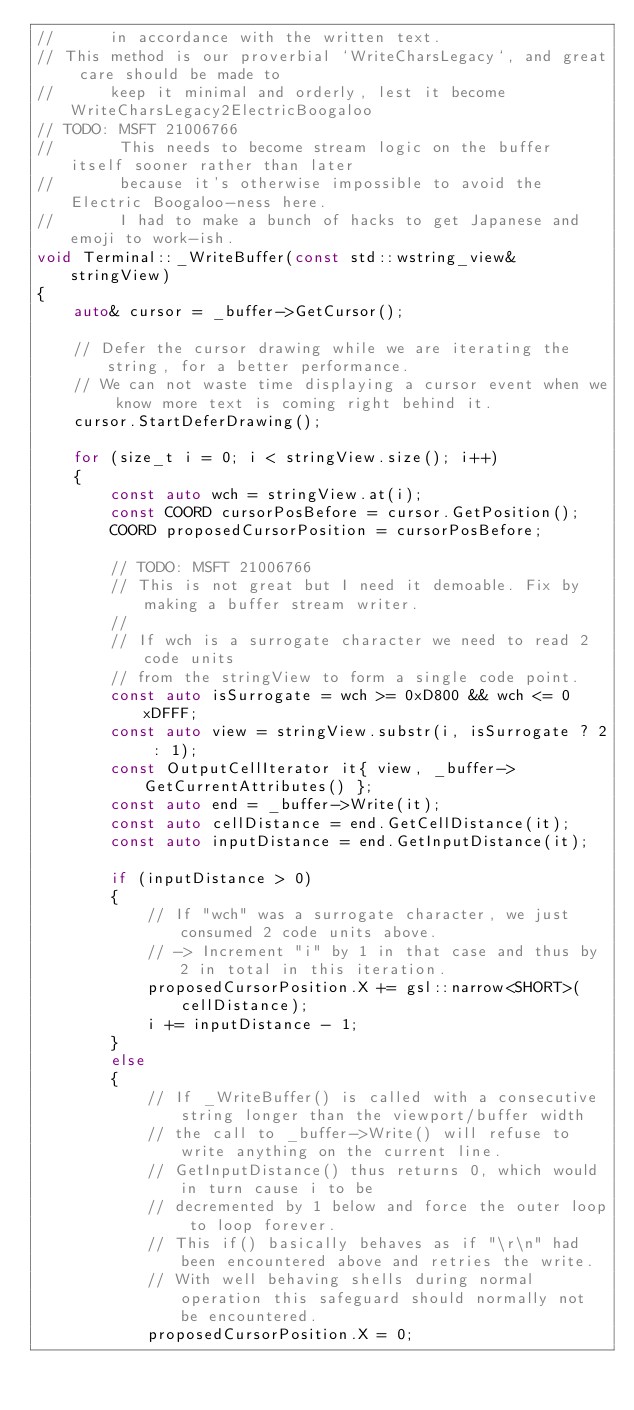<code> <loc_0><loc_0><loc_500><loc_500><_C++_>//      in accordance with the written text.
// This method is our proverbial `WriteCharsLegacy`, and great care should be made to
//      keep it minimal and orderly, lest it become WriteCharsLegacy2ElectricBoogaloo
// TODO: MSFT 21006766
//       This needs to become stream logic on the buffer itself sooner rather than later
//       because it's otherwise impossible to avoid the Electric Boogaloo-ness here.
//       I had to make a bunch of hacks to get Japanese and emoji to work-ish.
void Terminal::_WriteBuffer(const std::wstring_view& stringView)
{
    auto& cursor = _buffer->GetCursor();

    // Defer the cursor drawing while we are iterating the string, for a better performance.
    // We can not waste time displaying a cursor event when we know more text is coming right behind it.
    cursor.StartDeferDrawing();

    for (size_t i = 0; i < stringView.size(); i++)
    {
        const auto wch = stringView.at(i);
        const COORD cursorPosBefore = cursor.GetPosition();
        COORD proposedCursorPosition = cursorPosBefore;

        // TODO: MSFT 21006766
        // This is not great but I need it demoable. Fix by making a buffer stream writer.
        //
        // If wch is a surrogate character we need to read 2 code units
        // from the stringView to form a single code point.
        const auto isSurrogate = wch >= 0xD800 && wch <= 0xDFFF;
        const auto view = stringView.substr(i, isSurrogate ? 2 : 1);
        const OutputCellIterator it{ view, _buffer->GetCurrentAttributes() };
        const auto end = _buffer->Write(it);
        const auto cellDistance = end.GetCellDistance(it);
        const auto inputDistance = end.GetInputDistance(it);

        if (inputDistance > 0)
        {
            // If "wch" was a surrogate character, we just consumed 2 code units above.
            // -> Increment "i" by 1 in that case and thus by 2 in total in this iteration.
            proposedCursorPosition.X += gsl::narrow<SHORT>(cellDistance);
            i += inputDistance - 1;
        }
        else
        {
            // If _WriteBuffer() is called with a consecutive string longer than the viewport/buffer width
            // the call to _buffer->Write() will refuse to write anything on the current line.
            // GetInputDistance() thus returns 0, which would in turn cause i to be
            // decremented by 1 below and force the outer loop to loop forever.
            // This if() basically behaves as if "\r\n" had been encountered above and retries the write.
            // With well behaving shells during normal operation this safeguard should normally not be encountered.
            proposedCursorPosition.X = 0;</code> 